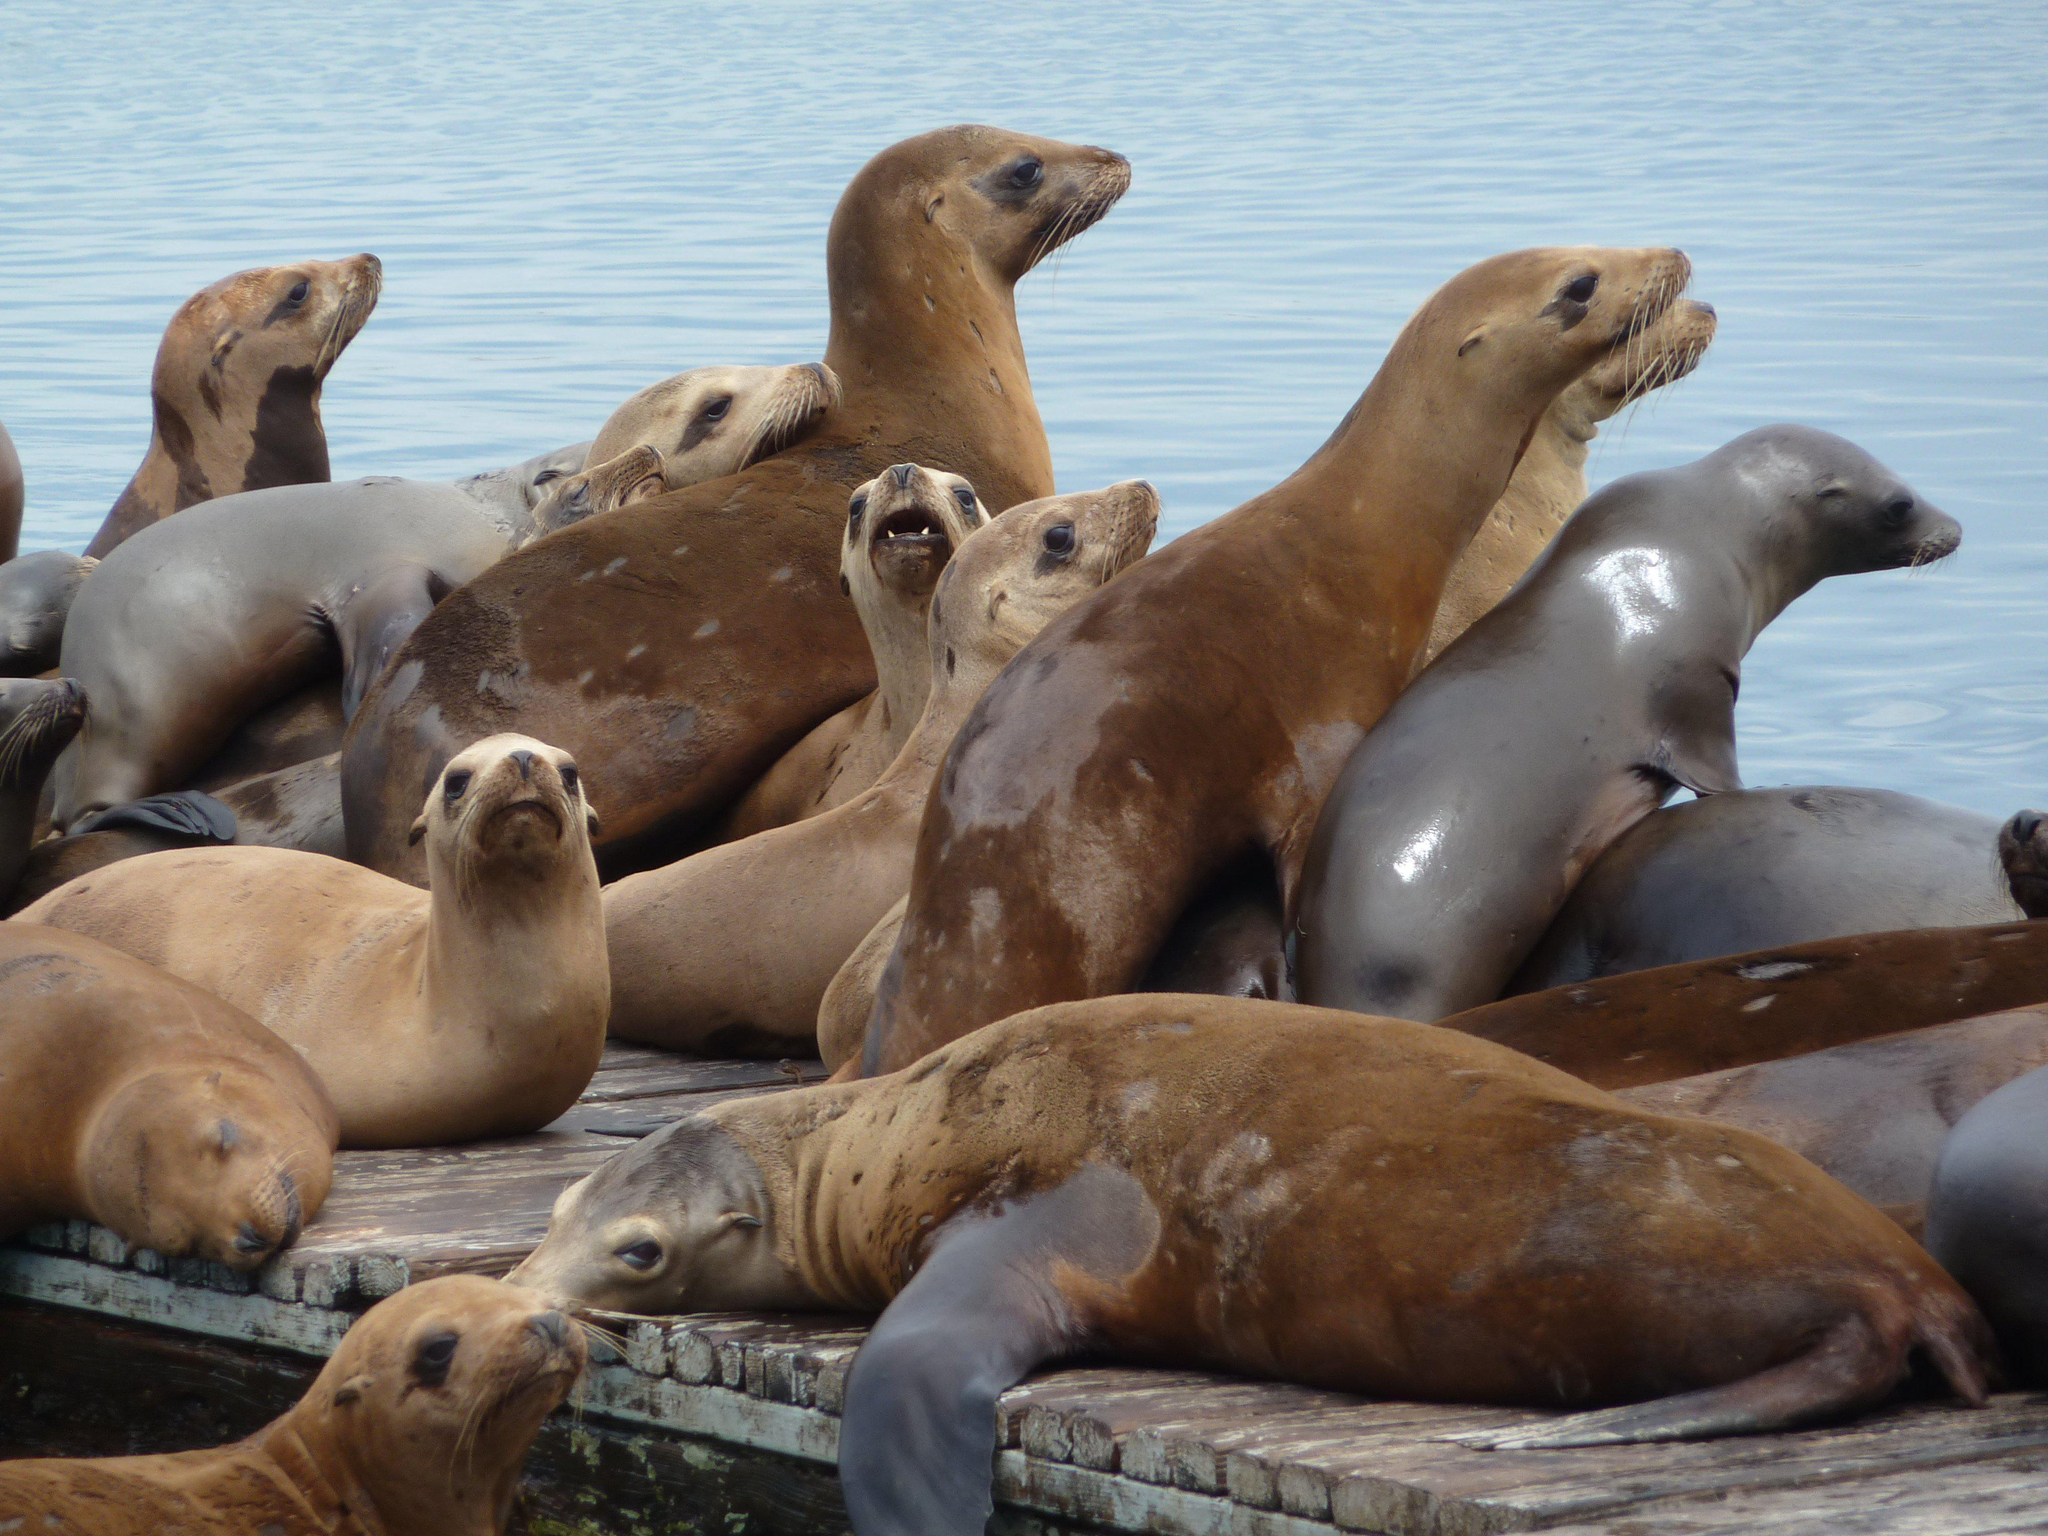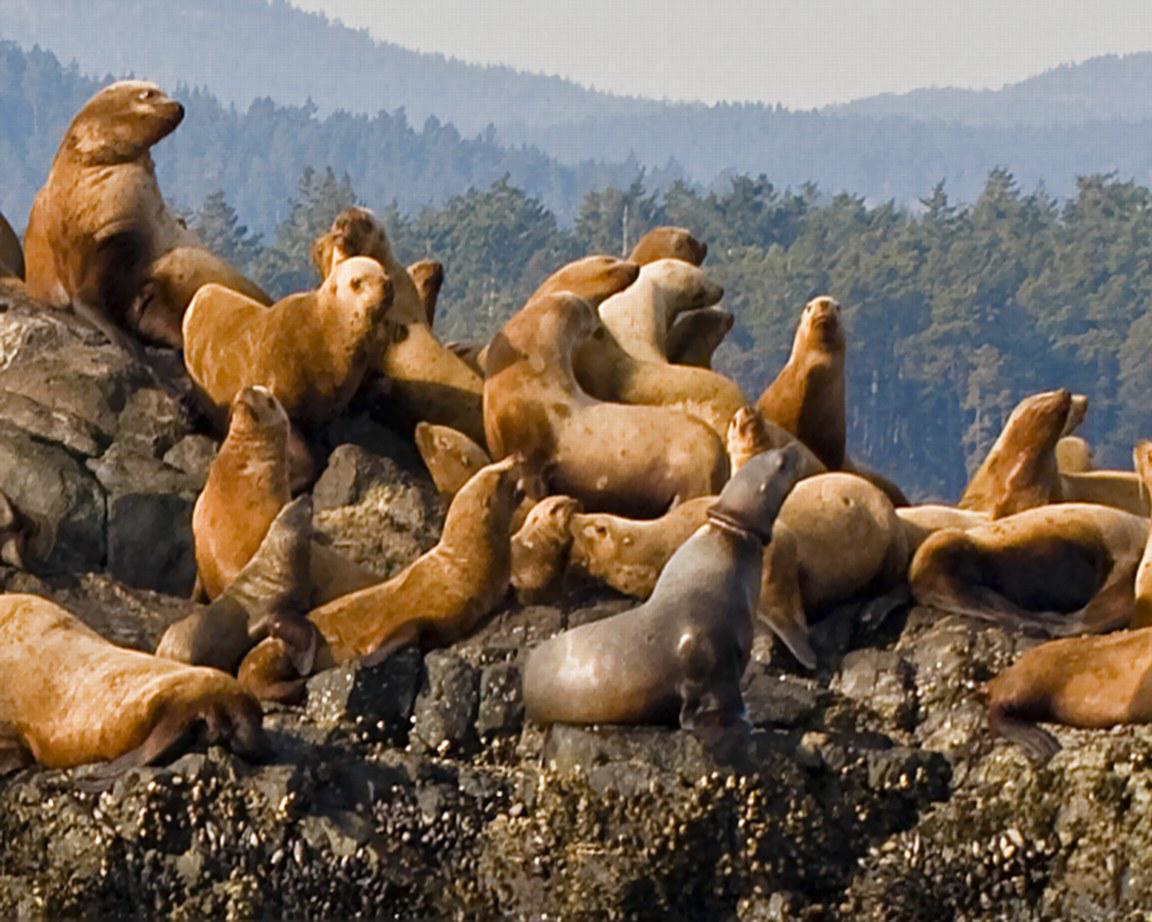The first image is the image on the left, the second image is the image on the right. For the images shown, is this caption "One image contains exactly three seals." true? Answer yes or no. No. 